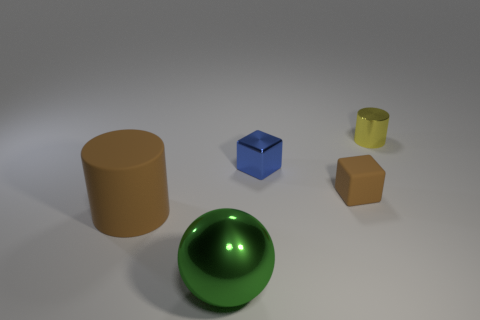Add 5 big rubber things. How many objects exist? 10 Subtract all balls. How many objects are left? 4 Add 3 green objects. How many green objects are left? 4 Add 4 large yellow metal cylinders. How many large yellow metal cylinders exist? 4 Subtract 0 red balls. How many objects are left? 5 Subtract all tiny cylinders. Subtract all tiny matte things. How many objects are left? 3 